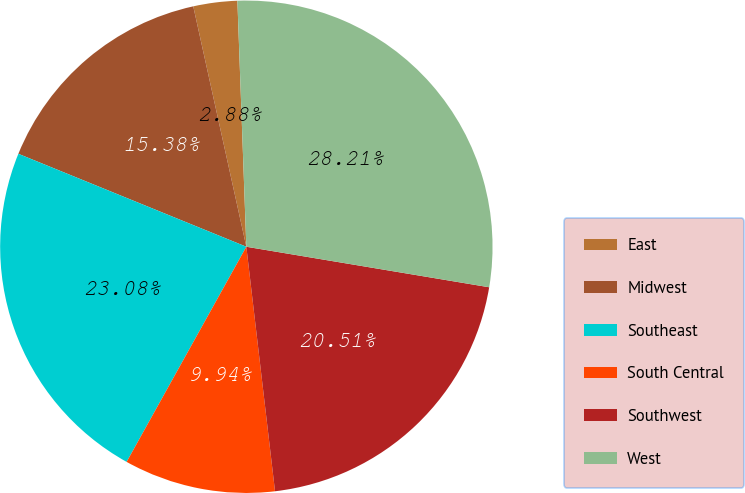Convert chart to OTSL. <chart><loc_0><loc_0><loc_500><loc_500><pie_chart><fcel>East<fcel>Midwest<fcel>Southeast<fcel>South Central<fcel>Southwest<fcel>West<nl><fcel>2.88%<fcel>15.38%<fcel>23.08%<fcel>9.94%<fcel>20.51%<fcel>28.21%<nl></chart> 